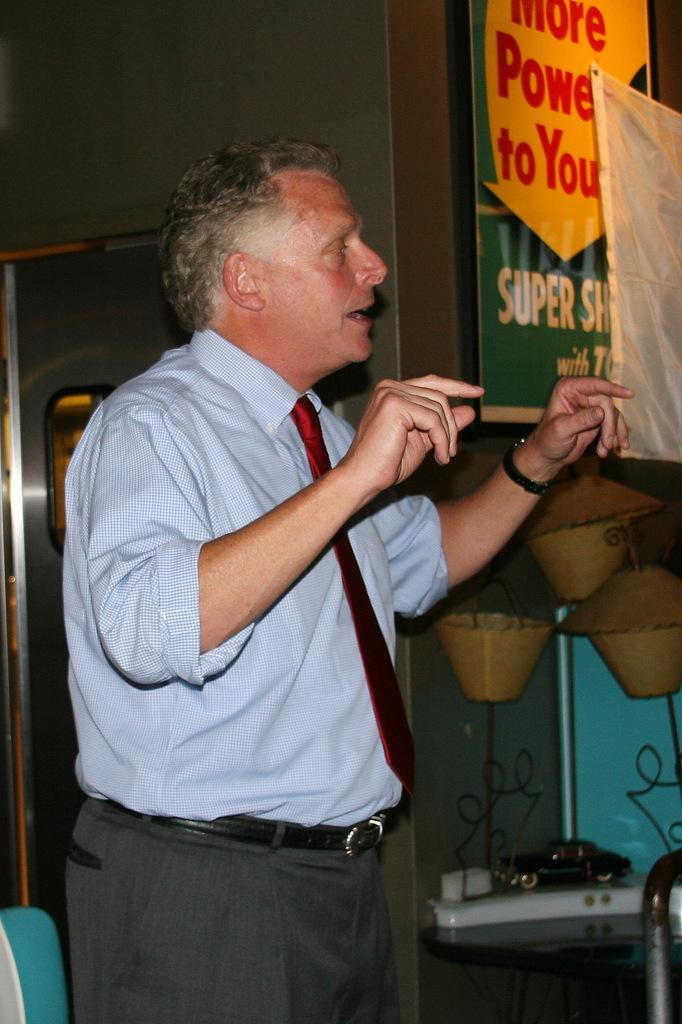Provide a one-sentence caption for the provided image. A man in a red tie stands near a sign that reads "more power to you". 